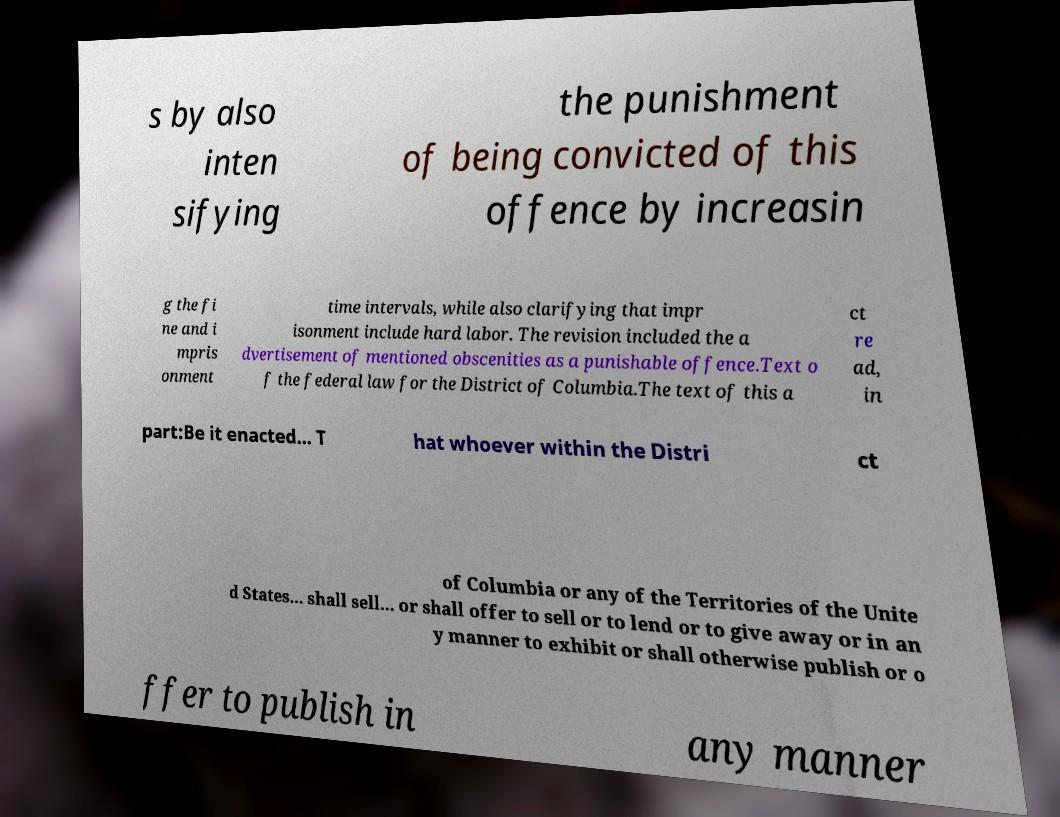What messages or text are displayed in this image? I need them in a readable, typed format. s by also inten sifying the punishment of being convicted of this offence by increasin g the fi ne and i mpris onment time intervals, while also clarifying that impr isonment include hard labor. The revision included the a dvertisement of mentioned obscenities as a punishable offence.Text o f the federal law for the District of Columbia.The text of this a ct re ad, in part:Be it enacted... T hat whoever within the Distri ct of Columbia or any of the Territories of the Unite d States... shall sell... or shall offer to sell or to lend or to give away or in an y manner to exhibit or shall otherwise publish or o ffer to publish in any manner 